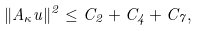Convert formula to latex. <formula><loc_0><loc_0><loc_500><loc_500>\| A _ { \kappa } u \| ^ { 2 } \leq C _ { 2 } + C _ { 4 } + C _ { 7 } ,</formula> 